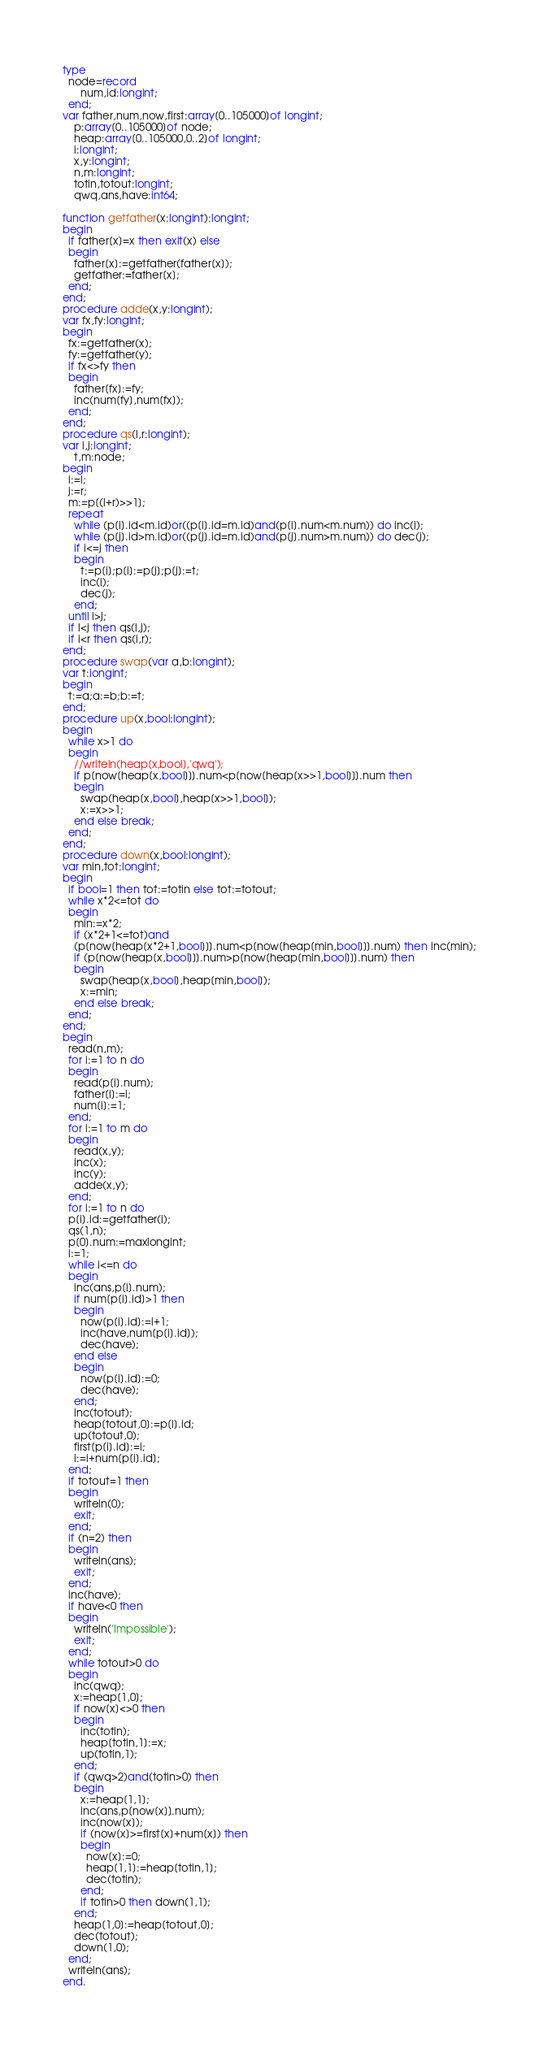<code> <loc_0><loc_0><loc_500><loc_500><_Pascal_>type
  node=record
      num,id:longint;
  end;
var father,num,now,first:array[0..105000]of longint;
    p:array[0..105000]of node;
    heap:array[0..105000,0..2]of longint;
    i:longint;
    x,y:longint;
    n,m:longint;
    totin,totout:longint;
    qwq,ans,have:int64;

function getfather(x:longint):longint;
begin
  if father[x]=x then exit(x) else
  begin
    father[x]:=getfather(father[x]);
    getfather:=father[x];
  end;
end;
procedure adde(x,y:longint);
var fx,fy:longint;
begin
  fx:=getfather(x);
  fy:=getfather(y);
  if fx<>fy then
  begin
    father[fx]:=fy;
    inc(num[fy],num[fx]);
  end;
end;
procedure qs(l,r:longint);
var i,j:longint;
    t,m:node;
begin
  i:=l;
  j:=r;
  m:=p[(l+r)>>1];
  repeat
    while (p[i].id<m.id)or((p[i].id=m.id)and(p[i].num<m.num)) do inc(i);
    while (p[j].id>m.id)or((p[j].id=m.id)and(p[j].num>m.num)) do dec(j);
    if i<=j then
    begin
      t:=p[i];p[i]:=p[j];p[j]:=t;
      inc(i);
      dec(j);
    end;
  until i>j;
  if l<j then qs(l,j);
  if i<r then qs(i,r);
end;
procedure swap(var a,b:longint);
var t:longint;
begin
  t:=a;a:=b;b:=t;
end;
procedure up(x,bool:longint);
begin
  while x>1 do
  begin
    //writeln(heap[x,bool],'qwq');
    if p[now[heap[x,bool]]].num<p[now[heap[x>>1,bool]]].num then
    begin
      swap(heap[x,bool],heap[x>>1,bool]);
      x:=x>>1;
    end else break;
  end;
end;
procedure down(x,bool:longint);
var min,tot:longint;
begin
  if bool=1 then tot:=totin else tot:=totout;
  while x*2<=tot do
  begin
    min:=x*2;
    if (x*2+1<=tot)and
    (p[now[heap[x*2+1,bool]]].num<p[now[heap[min,bool]]].num) then inc(min);
    if (p[now[heap[x,bool]]].num>p[now[heap[min,bool]]].num) then
    begin
      swap(heap[x,bool],heap[min,bool]);
      x:=min;
    end else break;
  end;
end;
begin
  read(n,m);
  for i:=1 to n do
  begin
    read(p[i].num);
    father[i]:=i;
    num[i]:=1;
  end;
  for i:=1 to m do
  begin
    read(x,y);
    inc(x);
    inc(y);
    adde(x,y);
  end;
  for i:=1 to n do
  p[i].id:=getfather(i);
  qs(1,n);
  p[0].num:=maxlongint;
  i:=1;
  while i<=n do
  begin
    inc(ans,p[i].num);
    if num[p[i].id]>1 then
    begin
      now[p[i].id]:=i+1;
      inc(have,num[p[i].id]);
      dec(have);
    end else
    begin
      now[p[i].id]:=0;
      dec(have);
    end;
    inc(totout);
    heap[totout,0]:=p[i].id;
    up(totout,0);
    first[p[i].id]:=i;
    i:=i+num[p[i].id];
  end;
  if totout=1 then
  begin
    writeln(0);
    exit;
  end;
  if (n=2) then
  begin
    writeln(ans);
    exit;
  end; 
  inc(have);
  if have<0 then
  begin
    writeln('Impossible');
    exit;
  end;
  while totout>0 do
  begin
    inc(qwq);
    x:=heap[1,0];
    if now[x]<>0 then
    begin
      inc(totin);
      heap[totin,1]:=x;
      up(totin,1);
    end;
    if (qwq>2)and(totin>0) then
    begin
      x:=heap[1,1];
      inc(ans,p[now[x]].num);
      inc(now[x]);
      if (now[x]>=first[x]+num[x]) then
      begin
        now[x]:=0;
        heap[1,1]:=heap[totin,1];
        dec(totin);
      end;
      if totin>0 then down(1,1);
    end;
    heap[1,0]:=heap[totout,0];
    dec(totout);
    down(1,0);
  end;
  writeln(ans);
end.
</code> 